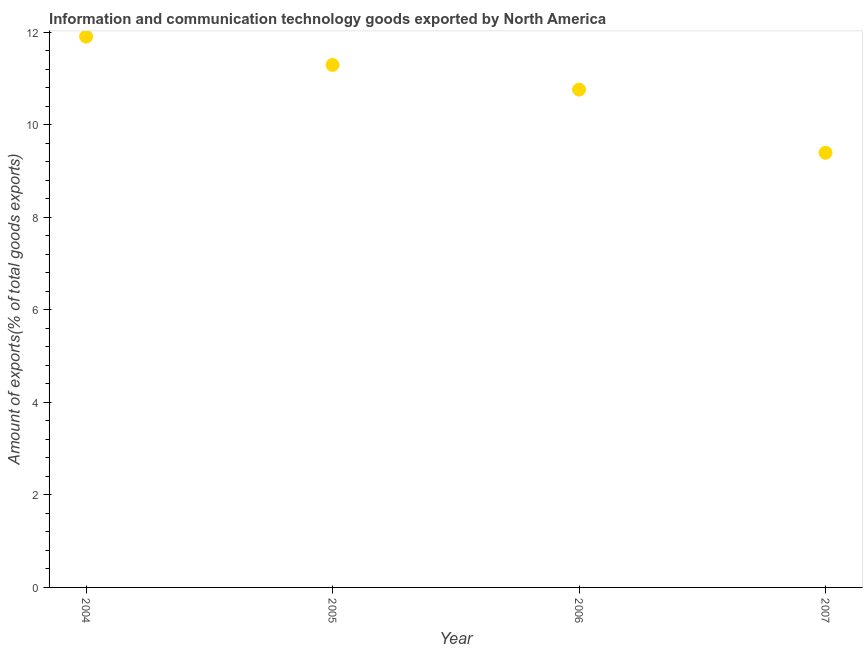What is the amount of ict goods exports in 2005?
Make the answer very short. 11.29. Across all years, what is the maximum amount of ict goods exports?
Offer a very short reply. 11.9. Across all years, what is the minimum amount of ict goods exports?
Provide a short and direct response. 9.39. In which year was the amount of ict goods exports maximum?
Offer a terse response. 2004. What is the sum of the amount of ict goods exports?
Keep it short and to the point. 43.35. What is the difference between the amount of ict goods exports in 2004 and 2005?
Keep it short and to the point. 0.61. What is the average amount of ict goods exports per year?
Keep it short and to the point. 10.84. What is the median amount of ict goods exports?
Your answer should be very brief. 11.03. In how many years, is the amount of ict goods exports greater than 1.6 %?
Provide a short and direct response. 4. What is the ratio of the amount of ict goods exports in 2005 to that in 2006?
Offer a very short reply. 1.05. Is the amount of ict goods exports in 2005 less than that in 2007?
Give a very brief answer. No. Is the difference between the amount of ict goods exports in 2005 and 2006 greater than the difference between any two years?
Give a very brief answer. No. What is the difference between the highest and the second highest amount of ict goods exports?
Your answer should be very brief. 0.61. What is the difference between the highest and the lowest amount of ict goods exports?
Offer a terse response. 2.51. Does the amount of ict goods exports monotonically increase over the years?
Provide a short and direct response. No. What is the difference between two consecutive major ticks on the Y-axis?
Keep it short and to the point. 2. Are the values on the major ticks of Y-axis written in scientific E-notation?
Provide a succinct answer. No. What is the title of the graph?
Keep it short and to the point. Information and communication technology goods exported by North America. What is the label or title of the X-axis?
Offer a terse response. Year. What is the label or title of the Y-axis?
Make the answer very short. Amount of exports(% of total goods exports). What is the Amount of exports(% of total goods exports) in 2004?
Provide a short and direct response. 11.9. What is the Amount of exports(% of total goods exports) in 2005?
Your answer should be compact. 11.29. What is the Amount of exports(% of total goods exports) in 2006?
Give a very brief answer. 10.76. What is the Amount of exports(% of total goods exports) in 2007?
Offer a terse response. 9.39. What is the difference between the Amount of exports(% of total goods exports) in 2004 and 2005?
Provide a succinct answer. 0.61. What is the difference between the Amount of exports(% of total goods exports) in 2004 and 2006?
Offer a very short reply. 1.15. What is the difference between the Amount of exports(% of total goods exports) in 2004 and 2007?
Provide a succinct answer. 2.51. What is the difference between the Amount of exports(% of total goods exports) in 2005 and 2006?
Ensure brevity in your answer.  0.53. What is the difference between the Amount of exports(% of total goods exports) in 2005 and 2007?
Your answer should be very brief. 1.9. What is the difference between the Amount of exports(% of total goods exports) in 2006 and 2007?
Keep it short and to the point. 1.36. What is the ratio of the Amount of exports(% of total goods exports) in 2004 to that in 2005?
Provide a succinct answer. 1.05. What is the ratio of the Amount of exports(% of total goods exports) in 2004 to that in 2006?
Offer a terse response. 1.11. What is the ratio of the Amount of exports(% of total goods exports) in 2004 to that in 2007?
Give a very brief answer. 1.27. What is the ratio of the Amount of exports(% of total goods exports) in 2005 to that in 2006?
Ensure brevity in your answer.  1.05. What is the ratio of the Amount of exports(% of total goods exports) in 2005 to that in 2007?
Your answer should be very brief. 1.2. What is the ratio of the Amount of exports(% of total goods exports) in 2006 to that in 2007?
Your answer should be very brief. 1.15. 